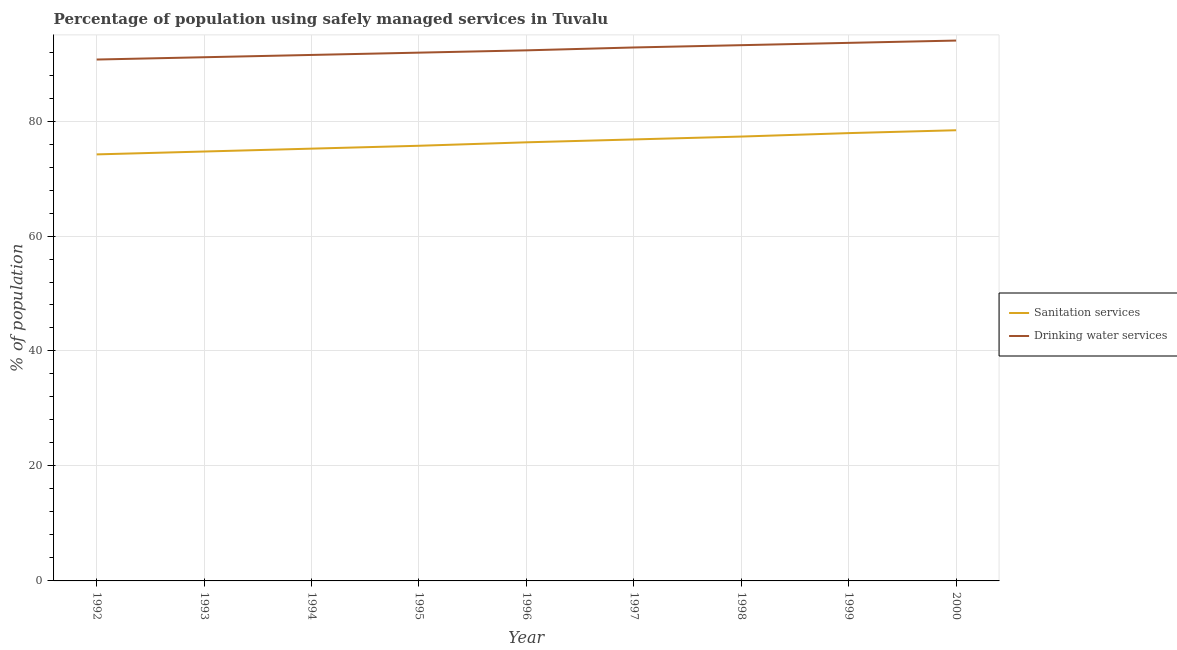How many different coloured lines are there?
Your response must be concise. 2. Is the number of lines equal to the number of legend labels?
Provide a short and direct response. Yes. What is the percentage of population who used sanitation services in 1997?
Provide a succinct answer. 76.8. Across all years, what is the maximum percentage of population who used drinking water services?
Keep it short and to the point. 94. Across all years, what is the minimum percentage of population who used sanitation services?
Give a very brief answer. 74.2. What is the total percentage of population who used sanitation services in the graph?
Offer a very short reply. 686.5. What is the difference between the percentage of population who used drinking water services in 1995 and that in 1997?
Ensure brevity in your answer.  -0.9. What is the difference between the percentage of population who used sanitation services in 1997 and the percentage of population who used drinking water services in 1996?
Offer a terse response. -15.5. What is the average percentage of population who used drinking water services per year?
Offer a very short reply. 92.34. In the year 2000, what is the difference between the percentage of population who used sanitation services and percentage of population who used drinking water services?
Keep it short and to the point. -15.6. In how many years, is the percentage of population who used drinking water services greater than 40 %?
Ensure brevity in your answer.  9. What is the ratio of the percentage of population who used sanitation services in 1993 to that in 1995?
Offer a terse response. 0.99. What is the difference between the highest and the second highest percentage of population who used drinking water services?
Offer a very short reply. 0.4. What is the difference between the highest and the lowest percentage of population who used drinking water services?
Provide a short and direct response. 3.3. Is the percentage of population who used sanitation services strictly greater than the percentage of population who used drinking water services over the years?
Provide a succinct answer. No. How many lines are there?
Your answer should be very brief. 2. What is the difference between two consecutive major ticks on the Y-axis?
Offer a terse response. 20. What is the title of the graph?
Your answer should be very brief. Percentage of population using safely managed services in Tuvalu. What is the label or title of the Y-axis?
Give a very brief answer. % of population. What is the % of population of Sanitation services in 1992?
Ensure brevity in your answer.  74.2. What is the % of population of Drinking water services in 1992?
Make the answer very short. 90.7. What is the % of population of Sanitation services in 1993?
Your answer should be compact. 74.7. What is the % of population in Drinking water services in 1993?
Your answer should be compact. 91.1. What is the % of population of Sanitation services in 1994?
Provide a short and direct response. 75.2. What is the % of population in Drinking water services in 1994?
Keep it short and to the point. 91.5. What is the % of population in Sanitation services in 1995?
Offer a very short reply. 75.7. What is the % of population of Drinking water services in 1995?
Your answer should be very brief. 91.9. What is the % of population in Sanitation services in 1996?
Your response must be concise. 76.3. What is the % of population of Drinking water services in 1996?
Keep it short and to the point. 92.3. What is the % of population of Sanitation services in 1997?
Offer a terse response. 76.8. What is the % of population in Drinking water services in 1997?
Keep it short and to the point. 92.8. What is the % of population in Sanitation services in 1998?
Keep it short and to the point. 77.3. What is the % of population in Drinking water services in 1998?
Provide a succinct answer. 93.2. What is the % of population of Sanitation services in 1999?
Keep it short and to the point. 77.9. What is the % of population of Drinking water services in 1999?
Your answer should be very brief. 93.6. What is the % of population in Sanitation services in 2000?
Offer a very short reply. 78.4. What is the % of population in Drinking water services in 2000?
Give a very brief answer. 94. Across all years, what is the maximum % of population in Sanitation services?
Keep it short and to the point. 78.4. Across all years, what is the maximum % of population in Drinking water services?
Make the answer very short. 94. Across all years, what is the minimum % of population of Sanitation services?
Provide a short and direct response. 74.2. Across all years, what is the minimum % of population of Drinking water services?
Your answer should be very brief. 90.7. What is the total % of population in Sanitation services in the graph?
Offer a terse response. 686.5. What is the total % of population in Drinking water services in the graph?
Offer a very short reply. 831.1. What is the difference between the % of population in Sanitation services in 1992 and that in 1993?
Ensure brevity in your answer.  -0.5. What is the difference between the % of population of Drinking water services in 1992 and that in 1994?
Provide a short and direct response. -0.8. What is the difference between the % of population in Sanitation services in 1992 and that in 1995?
Your answer should be compact. -1.5. What is the difference between the % of population of Sanitation services in 1992 and that in 1997?
Offer a very short reply. -2.6. What is the difference between the % of population in Drinking water services in 1992 and that in 1997?
Your answer should be compact. -2.1. What is the difference between the % of population in Drinking water services in 1992 and that in 1998?
Offer a terse response. -2.5. What is the difference between the % of population in Sanitation services in 1993 and that in 1994?
Offer a very short reply. -0.5. What is the difference between the % of population in Drinking water services in 1993 and that in 1994?
Keep it short and to the point. -0.4. What is the difference between the % of population in Sanitation services in 1993 and that in 1995?
Offer a terse response. -1. What is the difference between the % of population in Drinking water services in 1993 and that in 1995?
Keep it short and to the point. -0.8. What is the difference between the % of population of Drinking water services in 1993 and that in 1996?
Provide a succinct answer. -1.2. What is the difference between the % of population in Sanitation services in 1993 and that in 1997?
Provide a short and direct response. -2.1. What is the difference between the % of population of Drinking water services in 1993 and that in 1997?
Make the answer very short. -1.7. What is the difference between the % of population in Sanitation services in 1993 and that in 1998?
Keep it short and to the point. -2.6. What is the difference between the % of population of Drinking water services in 1993 and that in 1998?
Your answer should be very brief. -2.1. What is the difference between the % of population of Drinking water services in 1993 and that in 1999?
Make the answer very short. -2.5. What is the difference between the % of population in Sanitation services in 1994 and that in 1995?
Provide a short and direct response. -0.5. What is the difference between the % of population in Drinking water services in 1994 and that in 1996?
Make the answer very short. -0.8. What is the difference between the % of population in Sanitation services in 1994 and that in 1997?
Provide a short and direct response. -1.6. What is the difference between the % of population in Sanitation services in 1994 and that in 1998?
Give a very brief answer. -2.1. What is the difference between the % of population of Drinking water services in 1994 and that in 1998?
Make the answer very short. -1.7. What is the difference between the % of population of Sanitation services in 1994 and that in 1999?
Your answer should be very brief. -2.7. What is the difference between the % of population in Drinking water services in 1994 and that in 1999?
Provide a short and direct response. -2.1. What is the difference between the % of population of Sanitation services in 1994 and that in 2000?
Your answer should be very brief. -3.2. What is the difference between the % of population in Sanitation services in 1995 and that in 1996?
Your answer should be compact. -0.6. What is the difference between the % of population in Sanitation services in 1995 and that in 1997?
Offer a terse response. -1.1. What is the difference between the % of population in Sanitation services in 1995 and that in 1998?
Provide a succinct answer. -1.6. What is the difference between the % of population in Drinking water services in 1995 and that in 1999?
Provide a succinct answer. -1.7. What is the difference between the % of population of Sanitation services in 1995 and that in 2000?
Provide a succinct answer. -2.7. What is the difference between the % of population of Drinking water services in 1995 and that in 2000?
Your answer should be very brief. -2.1. What is the difference between the % of population of Sanitation services in 1996 and that in 1998?
Offer a terse response. -1. What is the difference between the % of population in Drinking water services in 1996 and that in 1998?
Keep it short and to the point. -0.9. What is the difference between the % of population of Sanitation services in 1996 and that in 1999?
Your answer should be compact. -1.6. What is the difference between the % of population of Sanitation services in 1996 and that in 2000?
Ensure brevity in your answer.  -2.1. What is the difference between the % of population in Drinking water services in 1996 and that in 2000?
Make the answer very short. -1.7. What is the difference between the % of population in Drinking water services in 1997 and that in 1998?
Give a very brief answer. -0.4. What is the difference between the % of population in Sanitation services in 1997 and that in 1999?
Offer a terse response. -1.1. What is the difference between the % of population in Sanitation services in 1997 and that in 2000?
Give a very brief answer. -1.6. What is the difference between the % of population in Drinking water services in 1998 and that in 1999?
Keep it short and to the point. -0.4. What is the difference between the % of population of Sanitation services in 1999 and that in 2000?
Offer a terse response. -0.5. What is the difference between the % of population of Sanitation services in 1992 and the % of population of Drinking water services in 1993?
Your response must be concise. -16.9. What is the difference between the % of population in Sanitation services in 1992 and the % of population in Drinking water services in 1994?
Give a very brief answer. -17.3. What is the difference between the % of population in Sanitation services in 1992 and the % of population in Drinking water services in 1995?
Make the answer very short. -17.7. What is the difference between the % of population of Sanitation services in 1992 and the % of population of Drinking water services in 1996?
Make the answer very short. -18.1. What is the difference between the % of population of Sanitation services in 1992 and the % of population of Drinking water services in 1997?
Give a very brief answer. -18.6. What is the difference between the % of population of Sanitation services in 1992 and the % of population of Drinking water services in 1999?
Your answer should be very brief. -19.4. What is the difference between the % of population of Sanitation services in 1992 and the % of population of Drinking water services in 2000?
Offer a very short reply. -19.8. What is the difference between the % of population of Sanitation services in 1993 and the % of population of Drinking water services in 1994?
Offer a very short reply. -16.8. What is the difference between the % of population in Sanitation services in 1993 and the % of population in Drinking water services in 1995?
Your answer should be compact. -17.2. What is the difference between the % of population of Sanitation services in 1993 and the % of population of Drinking water services in 1996?
Give a very brief answer. -17.6. What is the difference between the % of population of Sanitation services in 1993 and the % of population of Drinking water services in 1997?
Offer a very short reply. -18.1. What is the difference between the % of population of Sanitation services in 1993 and the % of population of Drinking water services in 1998?
Give a very brief answer. -18.5. What is the difference between the % of population of Sanitation services in 1993 and the % of population of Drinking water services in 1999?
Your answer should be very brief. -18.9. What is the difference between the % of population of Sanitation services in 1993 and the % of population of Drinking water services in 2000?
Give a very brief answer. -19.3. What is the difference between the % of population in Sanitation services in 1994 and the % of population in Drinking water services in 1995?
Ensure brevity in your answer.  -16.7. What is the difference between the % of population in Sanitation services in 1994 and the % of population in Drinking water services in 1996?
Keep it short and to the point. -17.1. What is the difference between the % of population in Sanitation services in 1994 and the % of population in Drinking water services in 1997?
Offer a terse response. -17.6. What is the difference between the % of population of Sanitation services in 1994 and the % of population of Drinking water services in 1999?
Offer a very short reply. -18.4. What is the difference between the % of population in Sanitation services in 1994 and the % of population in Drinking water services in 2000?
Offer a very short reply. -18.8. What is the difference between the % of population of Sanitation services in 1995 and the % of population of Drinking water services in 1996?
Offer a very short reply. -16.6. What is the difference between the % of population in Sanitation services in 1995 and the % of population in Drinking water services in 1997?
Make the answer very short. -17.1. What is the difference between the % of population of Sanitation services in 1995 and the % of population of Drinking water services in 1998?
Keep it short and to the point. -17.5. What is the difference between the % of population in Sanitation services in 1995 and the % of population in Drinking water services in 1999?
Ensure brevity in your answer.  -17.9. What is the difference between the % of population in Sanitation services in 1995 and the % of population in Drinking water services in 2000?
Provide a succinct answer. -18.3. What is the difference between the % of population in Sanitation services in 1996 and the % of population in Drinking water services in 1997?
Make the answer very short. -16.5. What is the difference between the % of population of Sanitation services in 1996 and the % of population of Drinking water services in 1998?
Your response must be concise. -16.9. What is the difference between the % of population of Sanitation services in 1996 and the % of population of Drinking water services in 1999?
Make the answer very short. -17.3. What is the difference between the % of population in Sanitation services in 1996 and the % of population in Drinking water services in 2000?
Offer a terse response. -17.7. What is the difference between the % of population of Sanitation services in 1997 and the % of population of Drinking water services in 1998?
Your response must be concise. -16.4. What is the difference between the % of population in Sanitation services in 1997 and the % of population in Drinking water services in 1999?
Give a very brief answer. -16.8. What is the difference between the % of population of Sanitation services in 1997 and the % of population of Drinking water services in 2000?
Your answer should be compact. -17.2. What is the difference between the % of population of Sanitation services in 1998 and the % of population of Drinking water services in 1999?
Keep it short and to the point. -16.3. What is the difference between the % of population in Sanitation services in 1998 and the % of population in Drinking water services in 2000?
Ensure brevity in your answer.  -16.7. What is the difference between the % of population of Sanitation services in 1999 and the % of population of Drinking water services in 2000?
Provide a short and direct response. -16.1. What is the average % of population in Sanitation services per year?
Give a very brief answer. 76.28. What is the average % of population in Drinking water services per year?
Offer a very short reply. 92.34. In the year 1992, what is the difference between the % of population in Sanitation services and % of population in Drinking water services?
Ensure brevity in your answer.  -16.5. In the year 1993, what is the difference between the % of population of Sanitation services and % of population of Drinking water services?
Give a very brief answer. -16.4. In the year 1994, what is the difference between the % of population of Sanitation services and % of population of Drinking water services?
Make the answer very short. -16.3. In the year 1995, what is the difference between the % of population of Sanitation services and % of population of Drinking water services?
Your answer should be compact. -16.2. In the year 1998, what is the difference between the % of population in Sanitation services and % of population in Drinking water services?
Your answer should be compact. -15.9. In the year 1999, what is the difference between the % of population in Sanitation services and % of population in Drinking water services?
Your answer should be very brief. -15.7. In the year 2000, what is the difference between the % of population of Sanitation services and % of population of Drinking water services?
Keep it short and to the point. -15.6. What is the ratio of the % of population in Sanitation services in 1992 to that in 1994?
Offer a terse response. 0.99. What is the ratio of the % of population of Sanitation services in 1992 to that in 1995?
Offer a very short reply. 0.98. What is the ratio of the % of population in Drinking water services in 1992 to that in 1995?
Your answer should be very brief. 0.99. What is the ratio of the % of population of Sanitation services in 1992 to that in 1996?
Offer a terse response. 0.97. What is the ratio of the % of population in Drinking water services in 1992 to that in 1996?
Give a very brief answer. 0.98. What is the ratio of the % of population of Sanitation services in 1992 to that in 1997?
Keep it short and to the point. 0.97. What is the ratio of the % of population in Drinking water services in 1992 to that in 1997?
Keep it short and to the point. 0.98. What is the ratio of the % of population in Sanitation services in 1992 to that in 1998?
Make the answer very short. 0.96. What is the ratio of the % of population in Drinking water services in 1992 to that in 1998?
Offer a terse response. 0.97. What is the ratio of the % of population of Sanitation services in 1992 to that in 1999?
Make the answer very short. 0.95. What is the ratio of the % of population in Drinking water services in 1992 to that in 1999?
Offer a very short reply. 0.97. What is the ratio of the % of population of Sanitation services in 1992 to that in 2000?
Provide a short and direct response. 0.95. What is the ratio of the % of population in Drinking water services in 1992 to that in 2000?
Keep it short and to the point. 0.96. What is the ratio of the % of population of Sanitation services in 1993 to that in 1994?
Your answer should be compact. 0.99. What is the ratio of the % of population of Sanitation services in 1993 to that in 1995?
Your response must be concise. 0.99. What is the ratio of the % of population in Sanitation services in 1993 to that in 1997?
Make the answer very short. 0.97. What is the ratio of the % of population of Drinking water services in 1993 to that in 1997?
Offer a very short reply. 0.98. What is the ratio of the % of population in Sanitation services in 1993 to that in 1998?
Your response must be concise. 0.97. What is the ratio of the % of population of Drinking water services in 1993 to that in 1998?
Give a very brief answer. 0.98. What is the ratio of the % of population of Sanitation services in 1993 to that in 1999?
Provide a short and direct response. 0.96. What is the ratio of the % of population of Drinking water services in 1993 to that in 1999?
Your answer should be very brief. 0.97. What is the ratio of the % of population in Sanitation services in 1993 to that in 2000?
Make the answer very short. 0.95. What is the ratio of the % of population in Drinking water services in 1993 to that in 2000?
Give a very brief answer. 0.97. What is the ratio of the % of population in Sanitation services in 1994 to that in 1995?
Offer a terse response. 0.99. What is the ratio of the % of population in Drinking water services in 1994 to that in 1995?
Offer a very short reply. 1. What is the ratio of the % of population of Sanitation services in 1994 to that in 1996?
Your answer should be very brief. 0.99. What is the ratio of the % of population of Drinking water services in 1994 to that in 1996?
Offer a terse response. 0.99. What is the ratio of the % of population of Sanitation services in 1994 to that in 1997?
Provide a succinct answer. 0.98. What is the ratio of the % of population in Drinking water services in 1994 to that in 1997?
Your answer should be compact. 0.99. What is the ratio of the % of population in Sanitation services in 1994 to that in 1998?
Ensure brevity in your answer.  0.97. What is the ratio of the % of population in Drinking water services in 1994 to that in 1998?
Your answer should be compact. 0.98. What is the ratio of the % of population in Sanitation services in 1994 to that in 1999?
Your answer should be very brief. 0.97. What is the ratio of the % of population of Drinking water services in 1994 to that in 1999?
Your answer should be compact. 0.98. What is the ratio of the % of population of Sanitation services in 1994 to that in 2000?
Your response must be concise. 0.96. What is the ratio of the % of population in Drinking water services in 1994 to that in 2000?
Provide a succinct answer. 0.97. What is the ratio of the % of population in Sanitation services in 1995 to that in 1997?
Provide a short and direct response. 0.99. What is the ratio of the % of population in Drinking water services in 1995 to that in 1997?
Keep it short and to the point. 0.99. What is the ratio of the % of population in Sanitation services in 1995 to that in 1998?
Offer a very short reply. 0.98. What is the ratio of the % of population in Drinking water services in 1995 to that in 1998?
Offer a terse response. 0.99. What is the ratio of the % of population of Sanitation services in 1995 to that in 1999?
Make the answer very short. 0.97. What is the ratio of the % of population of Drinking water services in 1995 to that in 1999?
Offer a terse response. 0.98. What is the ratio of the % of population of Sanitation services in 1995 to that in 2000?
Ensure brevity in your answer.  0.97. What is the ratio of the % of population in Drinking water services in 1995 to that in 2000?
Give a very brief answer. 0.98. What is the ratio of the % of population in Sanitation services in 1996 to that in 1998?
Your answer should be compact. 0.99. What is the ratio of the % of population of Drinking water services in 1996 to that in 1998?
Your answer should be very brief. 0.99. What is the ratio of the % of population of Sanitation services in 1996 to that in 1999?
Your answer should be compact. 0.98. What is the ratio of the % of population of Drinking water services in 1996 to that in 1999?
Make the answer very short. 0.99. What is the ratio of the % of population in Sanitation services in 1996 to that in 2000?
Your answer should be compact. 0.97. What is the ratio of the % of population in Drinking water services in 1996 to that in 2000?
Give a very brief answer. 0.98. What is the ratio of the % of population in Sanitation services in 1997 to that in 1998?
Keep it short and to the point. 0.99. What is the ratio of the % of population of Drinking water services in 1997 to that in 1998?
Ensure brevity in your answer.  1. What is the ratio of the % of population in Sanitation services in 1997 to that in 1999?
Give a very brief answer. 0.99. What is the ratio of the % of population of Sanitation services in 1997 to that in 2000?
Your answer should be very brief. 0.98. What is the ratio of the % of population in Drinking water services in 1997 to that in 2000?
Give a very brief answer. 0.99. What is the ratio of the % of population of Sanitation services in 1998 to that in 1999?
Your answer should be very brief. 0.99. What is the ratio of the % of population in Sanitation services in 1998 to that in 2000?
Give a very brief answer. 0.99. What is the ratio of the % of population of Drinking water services in 1998 to that in 2000?
Offer a terse response. 0.99. What is the ratio of the % of population in Sanitation services in 1999 to that in 2000?
Offer a very short reply. 0.99. What is the ratio of the % of population in Drinking water services in 1999 to that in 2000?
Your answer should be very brief. 1. What is the difference between the highest and the second highest % of population of Drinking water services?
Provide a short and direct response. 0.4. What is the difference between the highest and the lowest % of population of Drinking water services?
Provide a short and direct response. 3.3. 